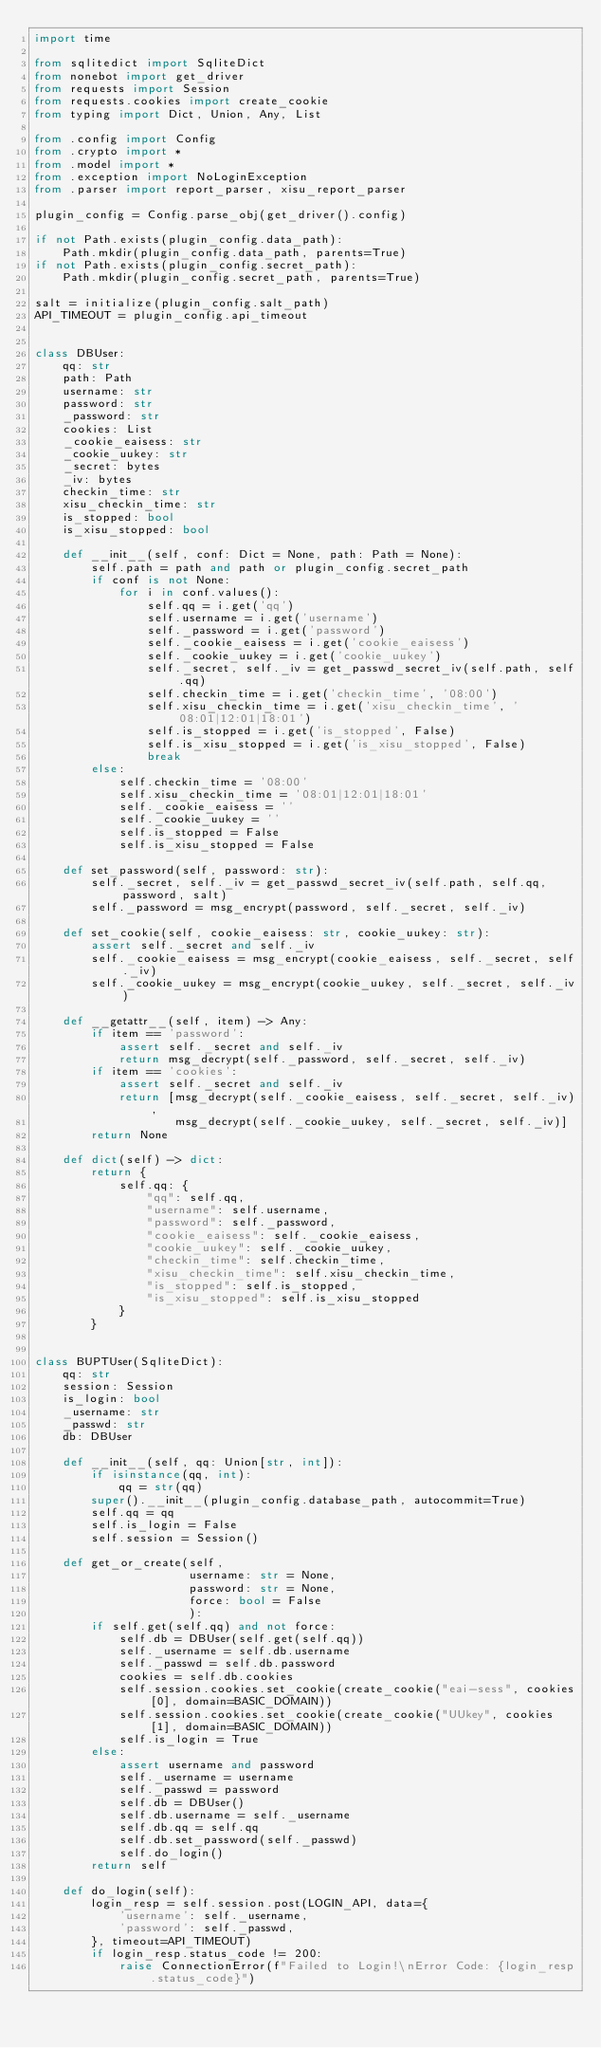Convert code to text. <code><loc_0><loc_0><loc_500><loc_500><_Python_>import time

from sqlitedict import SqliteDict
from nonebot import get_driver
from requests import Session
from requests.cookies import create_cookie
from typing import Dict, Union, Any, List

from .config import Config
from .crypto import *
from .model import *
from .exception import NoLoginException
from .parser import report_parser, xisu_report_parser

plugin_config = Config.parse_obj(get_driver().config)

if not Path.exists(plugin_config.data_path):
    Path.mkdir(plugin_config.data_path, parents=True)
if not Path.exists(plugin_config.secret_path):
    Path.mkdir(plugin_config.secret_path, parents=True)

salt = initialize(plugin_config.salt_path)
API_TIMEOUT = plugin_config.api_timeout


class DBUser:
    qq: str
    path: Path
    username: str
    password: str
    _password: str
    cookies: List
    _cookie_eaisess: str
    _cookie_uukey: str
    _secret: bytes
    _iv: bytes
    checkin_time: str
    xisu_checkin_time: str
    is_stopped: bool
    is_xisu_stopped: bool

    def __init__(self, conf: Dict = None, path: Path = None):
        self.path = path and path or plugin_config.secret_path
        if conf is not None:
            for i in conf.values():
                self.qq = i.get('qq')
                self.username = i.get('username')
                self._password = i.get('password')
                self._cookie_eaisess = i.get('cookie_eaisess')
                self._cookie_uukey = i.get('cookie_uukey')
                self._secret, self._iv = get_passwd_secret_iv(self.path, self.qq)
                self.checkin_time = i.get('checkin_time', '08:00')
                self.xisu_checkin_time = i.get('xisu_checkin_time', '08:01|12:01|18:01')
                self.is_stopped = i.get('is_stopped', False)
                self.is_xisu_stopped = i.get('is_xisu_stopped', False)
                break
        else:
            self.checkin_time = '08:00'
            self.xisu_checkin_time = '08:01|12:01|18:01'
            self._cookie_eaisess = ''
            self._cookie_uukey = ''
            self.is_stopped = False
            self.is_xisu_stopped = False

    def set_password(self, password: str):
        self._secret, self._iv = get_passwd_secret_iv(self.path, self.qq, password, salt)
        self._password = msg_encrypt(password, self._secret, self._iv)

    def set_cookie(self, cookie_eaisess: str, cookie_uukey: str):
        assert self._secret and self._iv
        self._cookie_eaisess = msg_encrypt(cookie_eaisess, self._secret, self._iv)
        self._cookie_uukey = msg_encrypt(cookie_uukey, self._secret, self._iv)

    def __getattr__(self, item) -> Any:
        if item == 'password':
            assert self._secret and self._iv
            return msg_decrypt(self._password, self._secret, self._iv)
        if item == 'cookies':
            assert self._secret and self._iv
            return [msg_decrypt(self._cookie_eaisess, self._secret, self._iv),
                    msg_decrypt(self._cookie_uukey, self._secret, self._iv)]
        return None

    def dict(self) -> dict:
        return {
            self.qq: {
                "qq": self.qq,
                "username": self.username,
                "password": self._password,
                "cookie_eaisess": self._cookie_eaisess,
                "cookie_uukey": self._cookie_uukey,
                "checkin_time": self.checkin_time,
                "xisu_checkin_time": self.xisu_checkin_time,
                "is_stopped": self.is_stopped,
                "is_xisu_stopped": self.is_xisu_stopped
            }
        }


class BUPTUser(SqliteDict):
    qq: str
    session: Session
    is_login: bool
    _username: str
    _passwd: str
    db: DBUser

    def __init__(self, qq: Union[str, int]):
        if isinstance(qq, int):
            qq = str(qq)
        super().__init__(plugin_config.database_path, autocommit=True)
        self.qq = qq
        self.is_login = False
        self.session = Session()

    def get_or_create(self,
                      username: str = None,
                      password: str = None,
                      force: bool = False
                      ):
        if self.get(self.qq) and not force:
            self.db = DBUser(self.get(self.qq))
            self._username = self.db.username
            self._passwd = self.db.password
            cookies = self.db.cookies
            self.session.cookies.set_cookie(create_cookie("eai-sess", cookies[0], domain=BASIC_DOMAIN))
            self.session.cookies.set_cookie(create_cookie("UUkey", cookies[1], domain=BASIC_DOMAIN))
            self.is_login = True
        else:
            assert username and password
            self._username = username
            self._passwd = password
            self.db = DBUser()
            self.db.username = self._username
            self.db.qq = self.qq
            self.db.set_password(self._passwd)
            self.do_login()
        return self

    def do_login(self):
        login_resp = self.session.post(LOGIN_API, data={
            'username': self._username,
            'password': self._passwd,
        }, timeout=API_TIMEOUT)
        if login_resp.status_code != 200:
            raise ConnectionError(f"Failed to Login!\nError Code: {login_resp.status_code}")</code> 